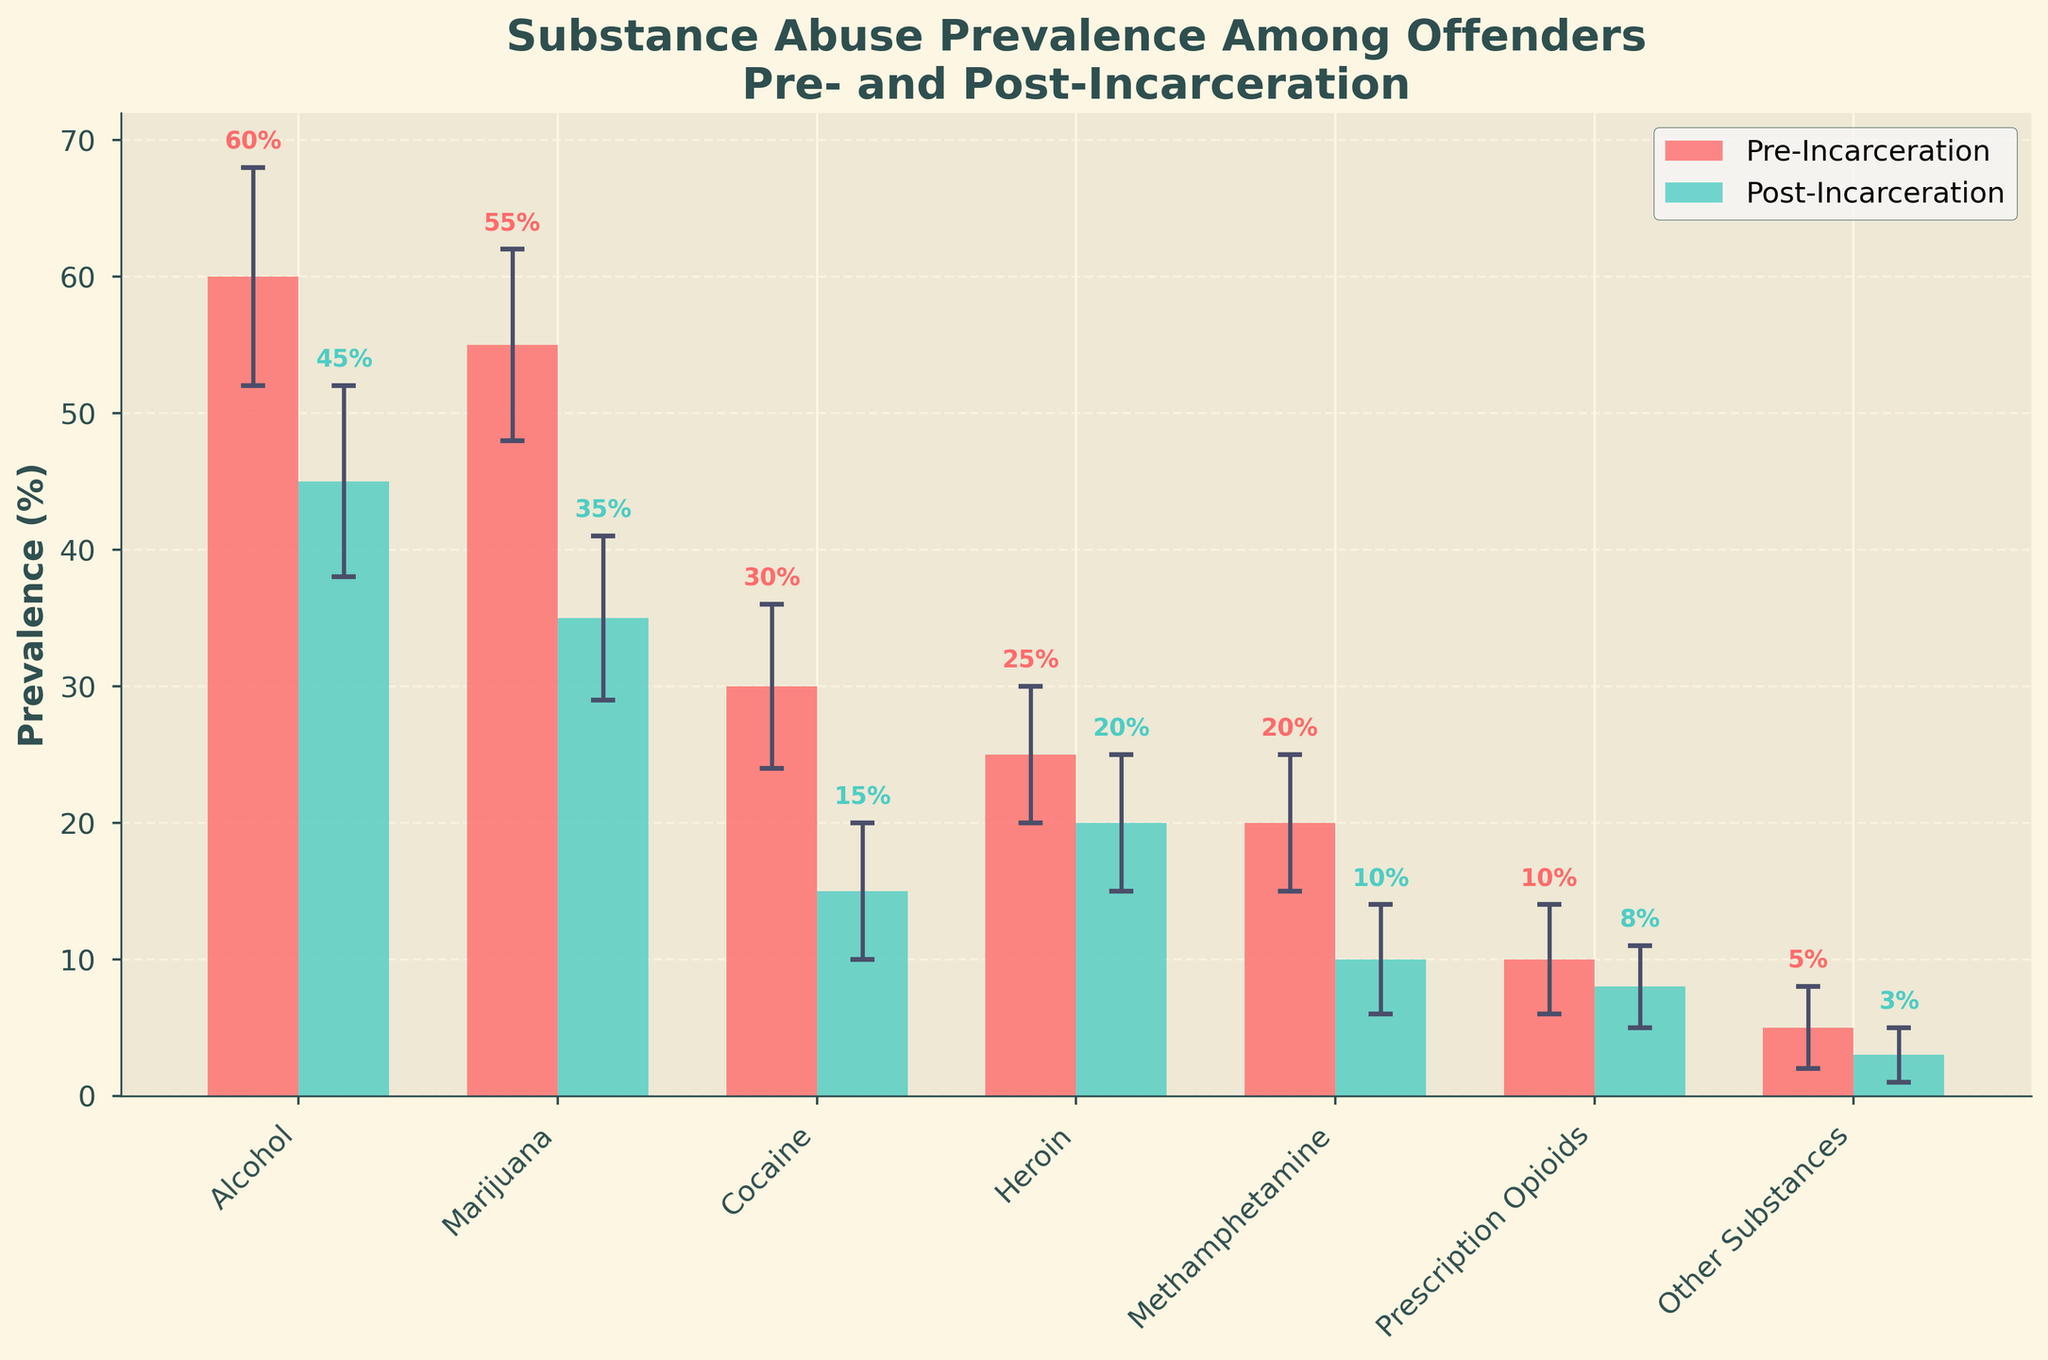What substances have the highest pre-incarceration abuse prevalence? According to the figure, the highest bars in the pre-incarceration category are for Alcohol and Marijuana.
Answer: Alcohol and Marijuana What is the difference in prevalence of alcohol abuse pre- and post-incarceration? The pre-incarceration prevalence for alcohol is around 60%, and the post-incarceration prevalence is around 45%. To find the difference, subtract the post-incarceration value from the pre-incarceration value (60% - 45%).
Answer: 15% What substance shows the smallest change in abuse prevalence from pre- to post-incarceration? By observing the heights of the bars and the error bars for both pre- and post-incarceration, Other Substances show the smallest change from 5% to 3%.
Answer: Other Substances Which substance has the highest standard deviation post-incarceration? The figure shows error bars representing standard deviations. Post-incarceration, Alcohol and Marijuana have the longest error bars at 7% and 6% respectively.
Answer: Alcohol How does the prevalence of cocaine use compare pre- and post-incarceration? The figure's bars indicate that cocaine use's pre-incarceration prevalence is around 30%, while post-incarceration it is around 15%. Thus, cocaine prevalence is lower post-incarceration.
Answer: Lower by 15% What is the combined average prevalence of pre-incarceration substance abuse for Cocaine and Heroin? To get the combined average prevalence, sum the pre-incarceration percentages for Cocaine (30%) and Heroin (25%) and divide by 2. (30% + 25%) / 2.
Answer: 27.5% Which substance has the biggest absolute reduction in prevalence from pre- to post-incarceration? By examining the difference in heights of the bars for pre- and post-incarceration, Marijuana shows the largest absolute reduction (55% - 35%).
Answer: Marijuana Is the prevalence of heroin use higher pre-incarceration or post-incarceration? To determine this, compare the bar heights for heroin pre- (25%) and post-incarceration (20%). The prevalence is higher pre-incarceration.
Answer: Pre-incarceration What substance has the lowest post-incarceration abuse prevalence? According to the figure, "Other Substances" has the lowest abuse prevalence post-incarceration with 3%.
Answer: Other Substances Which substance has the smallest standard deviation pre-incarceration? The error bars indicate the standard deviations, and "Other Substances" have the smallest standard deviation pre-incarceration at 3%.
Answer: Other Substances In the post-incarceration category, what is the standard deviation for prescription opioids? The error bar for prescription opioids in the post-incarceration category is around 3%.
Answer: 3% 